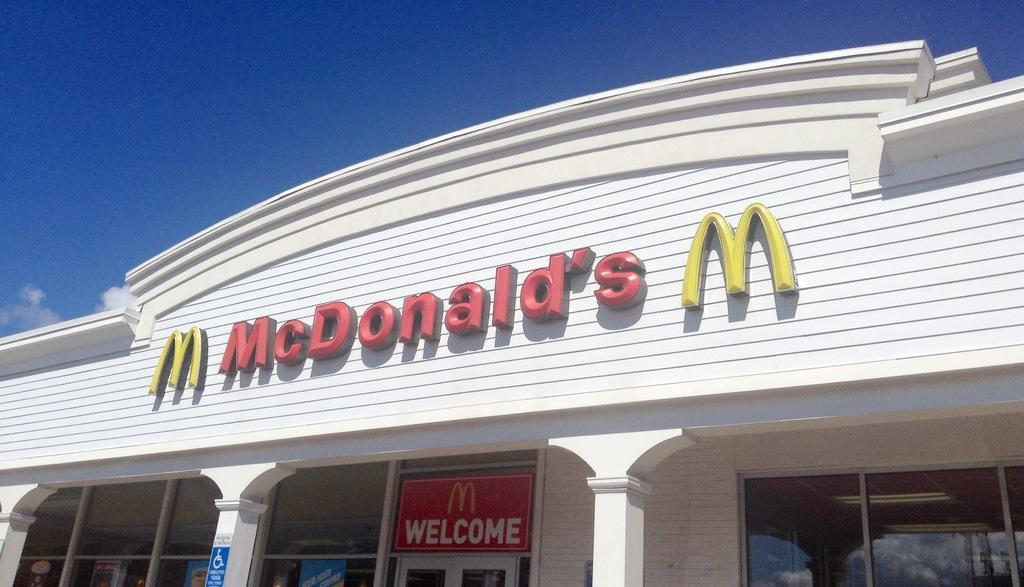How would you summarize this image in a sentence or two? In this image there is a building, there is a text on the wall of the building, there are pillars, name board visible at the bottom, at the top there is the sky. 